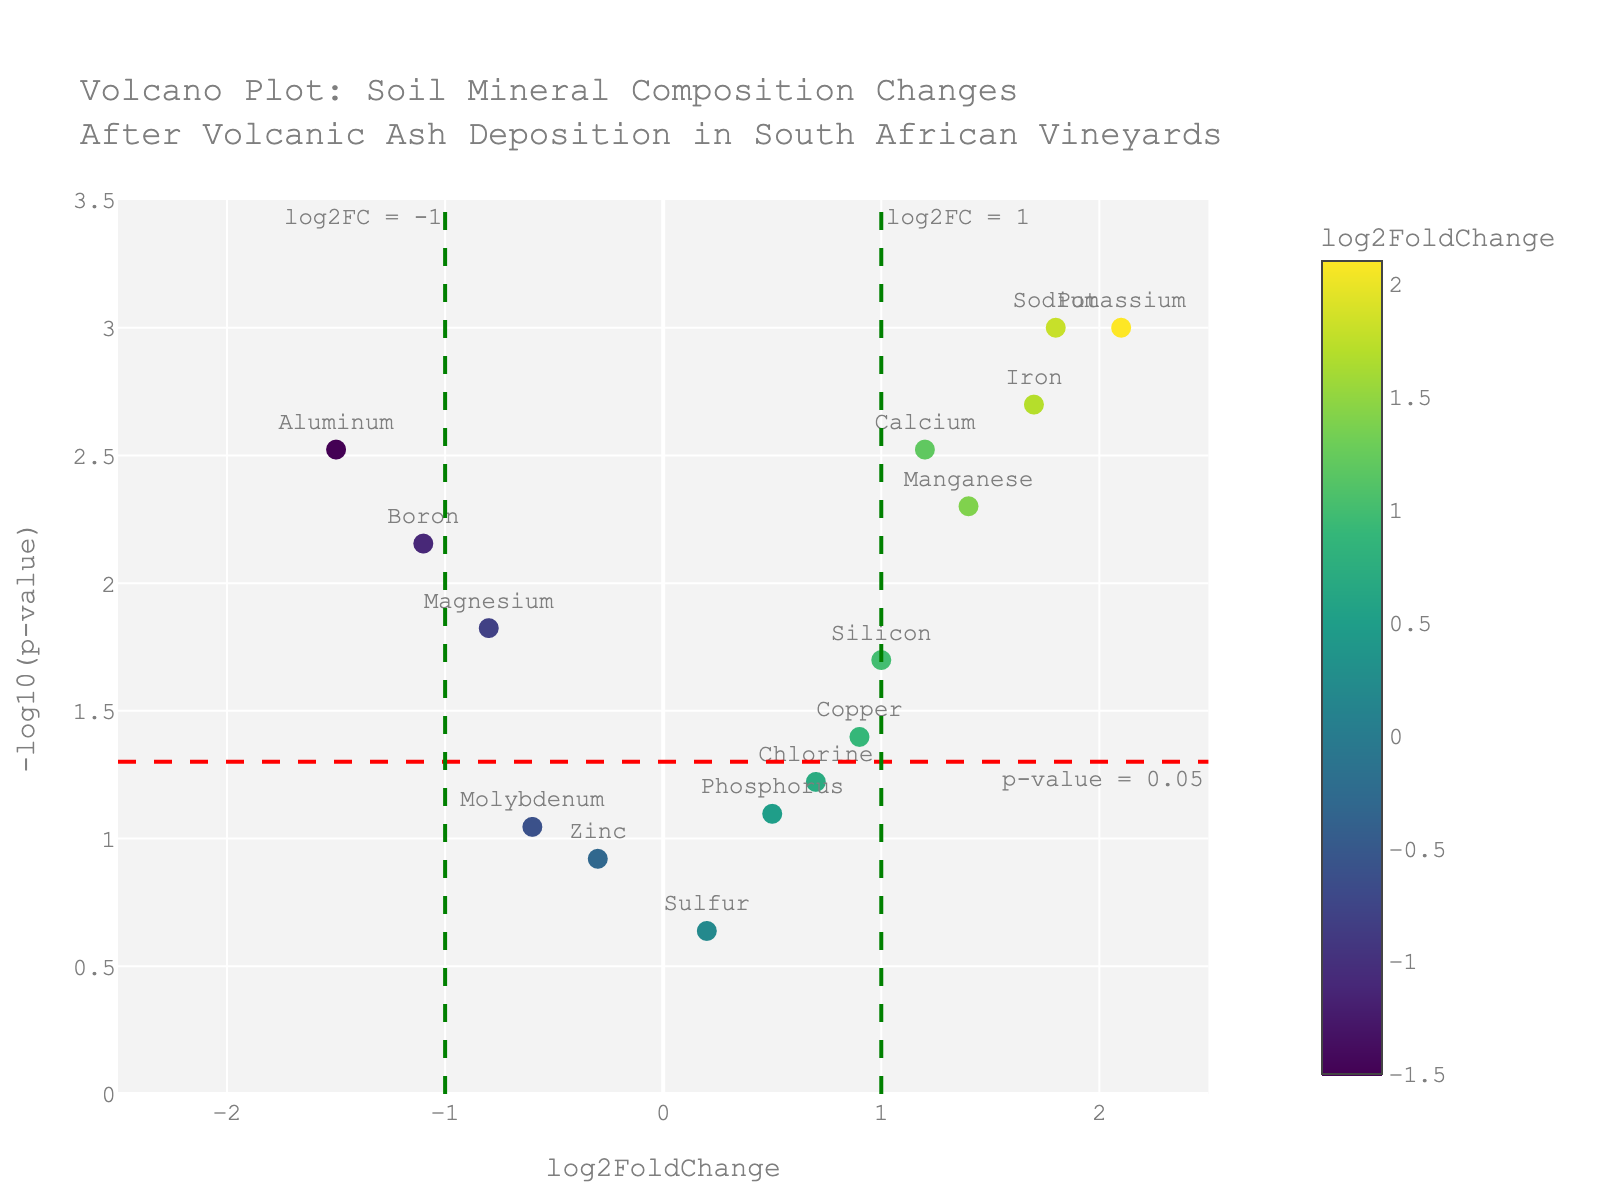How many minerals are plotted in the figure? Count the data points (markers) represented in the plot, each marker corresponds to a mineral. There are 15 minerals listed in the data.
Answer: 15 What is the title of the plot? The title is written at the top of the plot, usually in a larger or bold font.
Answer: Volcano Plot: Soil Mineral Composition Changes After Volcanic Ash Deposition in South African Vineyards Which mineral has the highest log2FoldChange? Locate the data point with the highest x-axis value (log2FoldChange). Potassium has the highest log2FoldChange value of 2.1.
Answer: Potassium Which mineral has the lowest p-value? Find the data point with the highest y-axis value (-log10(p-value)), as lower p-values correspond to higher -log10(p-values). Potassium, Sodium, and Iron all have the lowest p-value of 0.001.
Answer: Potassium How many minerals have a p-value less than 0.05? Identify all the points above the horizontal red line (which indicates p-value = 0.05). There are 10 such data points.
Answer: 10 What is the log2FoldChange and p-value of Aluminum? Locate Aluminum on the plot and retrieve the corresponding x-axis (log2FoldChange) and y-axis (-log10(p-value)) values. Aluminum has a log2FoldChange of -1.5 and a p-value of 0.003.
Answer: log2FoldChange: -1.5, p-value: 0.003 Which minerals show a significant increase in composition (p-value < 0.05 and log2FoldChange > 1)? Look at points with y-axis values greater than the threshold line (p-value < 0.05) and x-axis values greater than 1 (to the right of the vertical green line). This includes Potassium, Iron, Sodium, and Manganese.
Answer: Potassium, Iron, Sodium, Manganese Which minerals show a significant decrease in composition (p-value < 0.05 and log2FoldChange < -1)? Identify points that are above the horizontal red line (p-value < 0.05) and to the left of the left vertical green line (log2FoldChange < -1). This includes Boron and Aluminum.
Answer: Boron, Aluminum How does the log2FoldChange of Calcium compare to that of Magnesium? Compare the x-axis (log2FoldChange) values of Calcium and Magnesium. Calcium has a log2FoldChange of 1.2 and Magnesium has -0.8. Calcium's log2FoldChange is greater than Magnesium's.
Answer: Calcium > Magnesium What does the horizontal red line represent? The horizontal red line indicates a p-value of 0.05. Data points above this line have p-values less than 0.05, which are considered statistically significant.
Answer: p-value = 0.05 